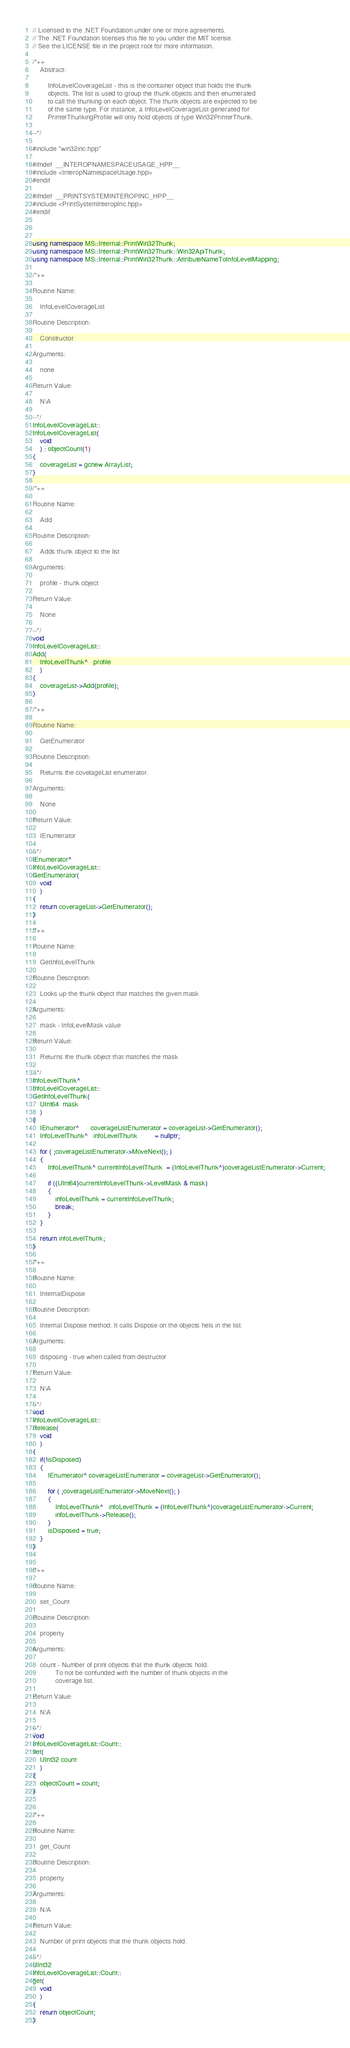Convert code to text. <code><loc_0><loc_0><loc_500><loc_500><_C++_>// Licensed to the .NET Foundation under one or more agreements.
// The .NET Foundation licenses this file to you under the MIT license.
// See the LICENSE file in the project root for more information.
        
/*++                                                                          
    Abstract:

        InfoLevelCoverageList - this is the container object that holds the thunk
        objects. The list is used to group the thunk objects and then enumerated
        to call the thunking on each object. The thunk objects are expected to be 
        of the same type. For instance, a InfoLevelCoverageList generated for 
        PrinterThunkingProfile will only hold objects of type Win32PrinterThunk.
        
--*/

#include "win32inc.hpp"

#ifndef  __INTEROPNAMESPACEUSAGE_HPP__
#include <InteropNamespaceUsage.hpp>
#endif

#ifndef  __PRINTSYSTEMINTEROPINC_HPP__
#include <PrintSystemInteropInc.hpp>
#endif 



using namespace MS::Internal::PrintWin32Thunk;
using namespace MS::Internal::PrintWin32Thunk::Win32ApiThunk;
using namespace MS::Internal::PrintWin32Thunk::AttributeNameToInfoLevelMapping;

/*++

Routine Name:   

    InfoLevelCoverageList

Routine Description:

    Constructor 

Arguments:

    none
    
Return Value:

    N\A

--*/
InfoLevelCoverageList::
InfoLevelCoverageList(
    void
    ) : objectCount(1)
{
    coverageList = gcnew ArrayList;
}

/*++

Routine Name:   

    Add

Routine Description:

    Adds thunk object to the list

Arguments:

    profile - thunk object
    
Return Value:

    None

--*/
void
InfoLevelCoverageList::
Add(
    InfoLevelThunk^   profile
    )
{
    coverageList->Add(profile);
}

/*++

Routine Name:   

    GetEnumerator

Routine Description:

    Returns the covelageList enumerator.

Arguments:

    None
    
Return Value:

    IEnumerator

--*/
IEnumerator^
InfoLevelCoverageList::
GetEnumerator(
    void
    )
{
    return coverageList->GetEnumerator();
}

/*++

Routine Name:   

    GetInfoLevelThunk

Routine Description:

    Looks up the thunk object that matches the given mask

Arguments:

    mask - InfoLevelMask value
    
Return Value:

    Returns the thunk object that matches the mask

--*/
InfoLevelThunk^
InfoLevelCoverageList::
GetInfoLevelThunk(
    UInt64  mask
    )
{
    IEnumerator^      coverageListEnumerator = coverageList->GetEnumerator();
    InfoLevelThunk^   infoLevelThunk         = nullptr;
            
    for ( ;coverageListEnumerator->MoveNext(); )
    {
        InfoLevelThunk^ currentInfoLevelThunk  = (InfoLevelThunk^)coverageListEnumerator->Current;
        
        if ((UInt64)currentInfoLevelThunk->LevelMask & mask)
        {
            infoLevelThunk = currentInfoLevelThunk;
            break;
        }        
    }

    return infoLevelThunk;
}

/*++

Routine Name:   

    InternalDispose

Routine Description:

    Internal Dispose method. It calls Dispose on the objects hels in the list.

Arguments:

    disposing - true when called from destructor
    
Return Value:

    N\A

--*/
void
InfoLevelCoverageList::
Release(
    void
    )
{
    if(!isDisposed)
    {
        IEnumerator^ coverageListEnumerator = coverageList->GetEnumerator();
        
        for ( ;coverageListEnumerator->MoveNext(); )
        {
            InfoLevelThunk^   infoLevelThunk = (InfoLevelThunk^)coverageListEnumerator->Current;
            infoLevelThunk->Release();
        }
        isDisposed = true;
    }
}


/*++

Routine Name:   

    set_Count

Routine Description:

    property

Arguments:

    count - Number of print objects that the thunk objects hold.
            To not be confunded with the number of thunk objects in the 
            coverage list.
    
Return Value:

    N\A

--*/
void
InfoLevelCoverageList::Count::
set(
    UInt32 count
    )
{
    objectCount = count;
}


/*++

Routine Name:   

    get_Count

Routine Description:

    property

Arguments:

    N/A
    
Return Value:

    Number of print objects that the thunk objects hold.

--*/
UInt32
InfoLevelCoverageList::Count::
get(
    void
    )
{
    return objectCount;
}

</code> 